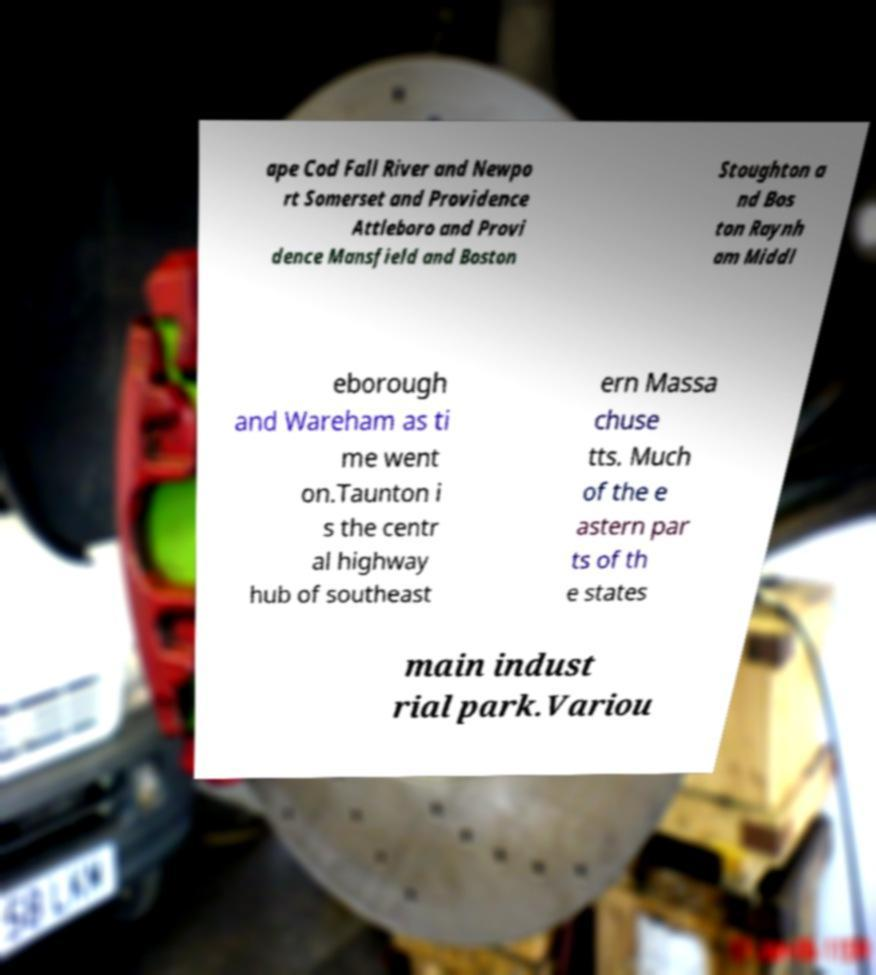Could you extract and type out the text from this image? ape Cod Fall River and Newpo rt Somerset and Providence Attleboro and Provi dence Mansfield and Boston Stoughton a nd Bos ton Raynh am Middl eborough and Wareham as ti me went on.Taunton i s the centr al highway hub of southeast ern Massa chuse tts. Much of the e astern par ts of th e states main indust rial park.Variou 